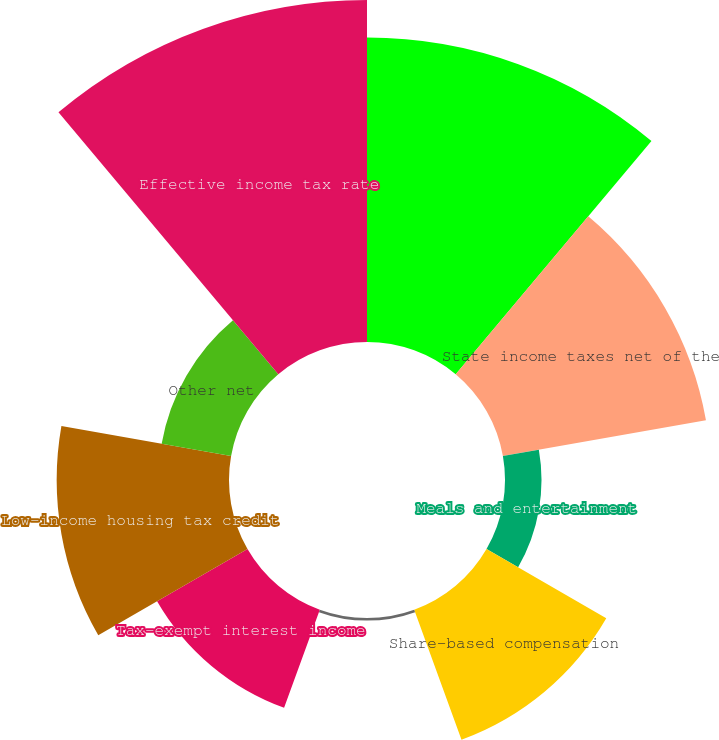<chart> <loc_0><loc_0><loc_500><loc_500><pie_chart><fcel>Federal statutory income tax<fcel>State income taxes net of the<fcel>Meals and entertainment<fcel>Share-based compensation<fcel>Disallowed officer's<fcel>Tax-exempt interest income<fcel>Low-income housing tax credit<fcel>Other net<fcel>Effective income tax rate<nl><fcel>22.11%<fcel>14.97%<fcel>2.65%<fcel>10.04%<fcel>0.19%<fcel>7.58%<fcel>12.51%<fcel>5.12%<fcel>24.83%<nl></chart> 